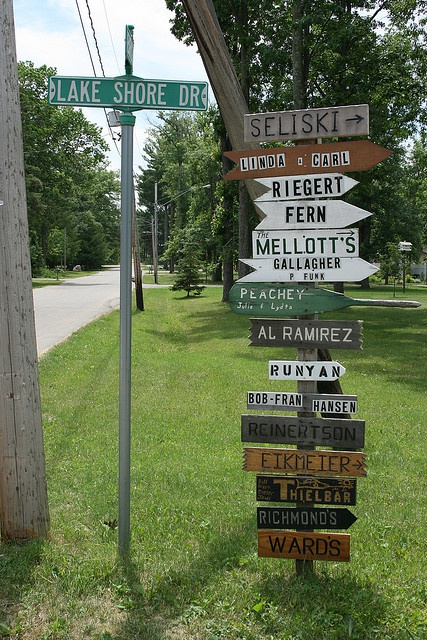Describe the objects in this image and their specific colors. I can see various objects in this image with different colors. 